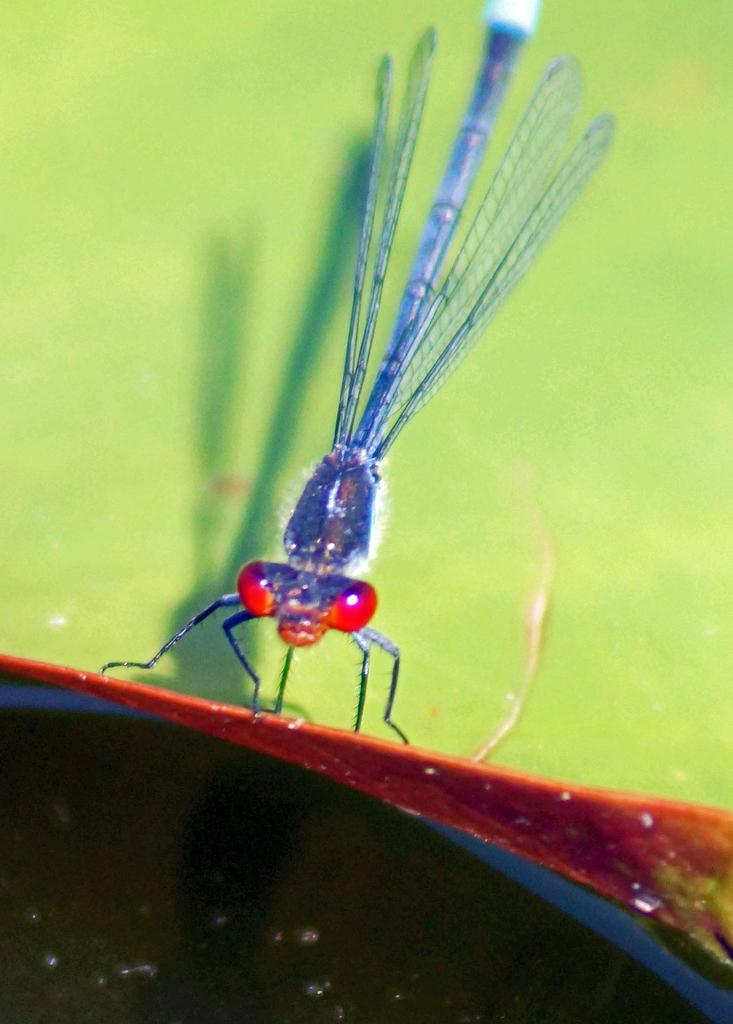What type of insect is in the image? There is a blue dragonfly in the image. What color are the dragonfly's eyes? The dragonfly has red eyes. Where is the dragonfly located in the image? The dragonfly is on a surface. What color is the background of the image? The background of the image is green. What type of pot is visible in the image? There is no pot present in the image; it features a blue dragonfly with red eyes on a surface. 